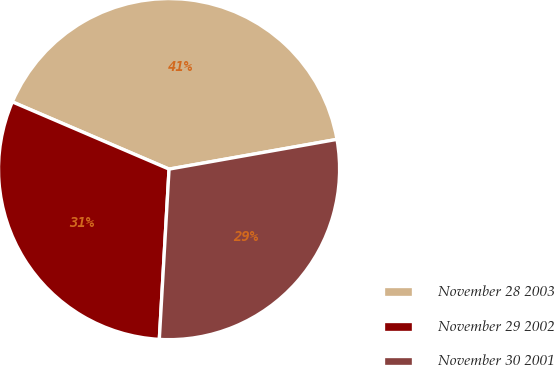Convert chart to OTSL. <chart><loc_0><loc_0><loc_500><loc_500><pie_chart><fcel>November 28 2003<fcel>November 29 2002<fcel>November 30 2001<nl><fcel>40.76%<fcel>30.54%<fcel>28.7%<nl></chart> 